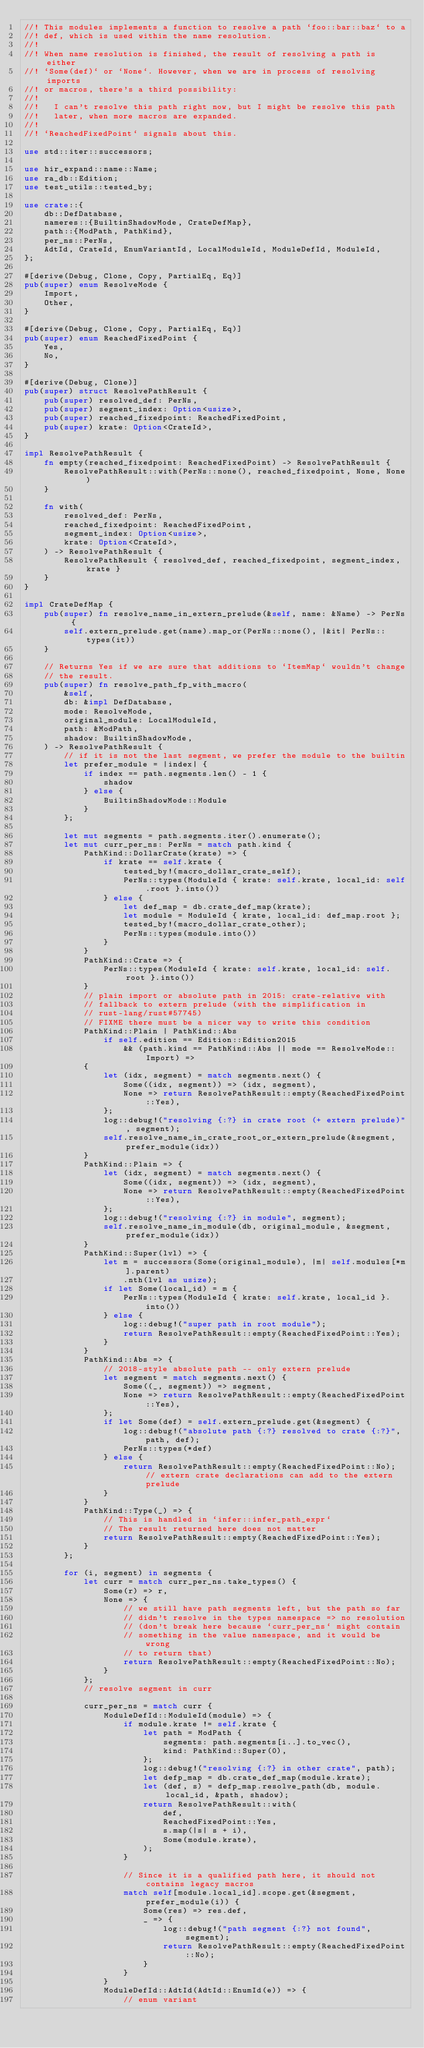Convert code to text. <code><loc_0><loc_0><loc_500><loc_500><_Rust_>//! This modules implements a function to resolve a path `foo::bar::baz` to a
//! def, which is used within the name resolution.
//!
//! When name resolution is finished, the result of resolving a path is either
//! `Some(def)` or `None`. However, when we are in process of resolving imports
//! or macros, there's a third possibility:
//!
//!   I can't resolve this path right now, but I might be resolve this path
//!   later, when more macros are expanded.
//!
//! `ReachedFixedPoint` signals about this.

use std::iter::successors;

use hir_expand::name::Name;
use ra_db::Edition;
use test_utils::tested_by;

use crate::{
    db::DefDatabase,
    nameres::{BuiltinShadowMode, CrateDefMap},
    path::{ModPath, PathKind},
    per_ns::PerNs,
    AdtId, CrateId, EnumVariantId, LocalModuleId, ModuleDefId, ModuleId,
};

#[derive(Debug, Clone, Copy, PartialEq, Eq)]
pub(super) enum ResolveMode {
    Import,
    Other,
}

#[derive(Debug, Clone, Copy, PartialEq, Eq)]
pub(super) enum ReachedFixedPoint {
    Yes,
    No,
}

#[derive(Debug, Clone)]
pub(super) struct ResolvePathResult {
    pub(super) resolved_def: PerNs,
    pub(super) segment_index: Option<usize>,
    pub(super) reached_fixedpoint: ReachedFixedPoint,
    pub(super) krate: Option<CrateId>,
}

impl ResolvePathResult {
    fn empty(reached_fixedpoint: ReachedFixedPoint) -> ResolvePathResult {
        ResolvePathResult::with(PerNs::none(), reached_fixedpoint, None, None)
    }

    fn with(
        resolved_def: PerNs,
        reached_fixedpoint: ReachedFixedPoint,
        segment_index: Option<usize>,
        krate: Option<CrateId>,
    ) -> ResolvePathResult {
        ResolvePathResult { resolved_def, reached_fixedpoint, segment_index, krate }
    }
}

impl CrateDefMap {
    pub(super) fn resolve_name_in_extern_prelude(&self, name: &Name) -> PerNs {
        self.extern_prelude.get(name).map_or(PerNs::none(), |&it| PerNs::types(it))
    }

    // Returns Yes if we are sure that additions to `ItemMap` wouldn't change
    // the result.
    pub(super) fn resolve_path_fp_with_macro(
        &self,
        db: &impl DefDatabase,
        mode: ResolveMode,
        original_module: LocalModuleId,
        path: &ModPath,
        shadow: BuiltinShadowMode,
    ) -> ResolvePathResult {
        // if it is not the last segment, we prefer the module to the builtin
        let prefer_module = |index| {
            if index == path.segments.len() - 1 {
                shadow
            } else {
                BuiltinShadowMode::Module
            }
        };

        let mut segments = path.segments.iter().enumerate();
        let mut curr_per_ns: PerNs = match path.kind {
            PathKind::DollarCrate(krate) => {
                if krate == self.krate {
                    tested_by!(macro_dollar_crate_self);
                    PerNs::types(ModuleId { krate: self.krate, local_id: self.root }.into())
                } else {
                    let def_map = db.crate_def_map(krate);
                    let module = ModuleId { krate, local_id: def_map.root };
                    tested_by!(macro_dollar_crate_other);
                    PerNs::types(module.into())
                }
            }
            PathKind::Crate => {
                PerNs::types(ModuleId { krate: self.krate, local_id: self.root }.into())
            }
            // plain import or absolute path in 2015: crate-relative with
            // fallback to extern prelude (with the simplification in
            // rust-lang/rust#57745)
            // FIXME there must be a nicer way to write this condition
            PathKind::Plain | PathKind::Abs
                if self.edition == Edition::Edition2015
                    && (path.kind == PathKind::Abs || mode == ResolveMode::Import) =>
            {
                let (idx, segment) = match segments.next() {
                    Some((idx, segment)) => (idx, segment),
                    None => return ResolvePathResult::empty(ReachedFixedPoint::Yes),
                };
                log::debug!("resolving {:?} in crate root (+ extern prelude)", segment);
                self.resolve_name_in_crate_root_or_extern_prelude(&segment, prefer_module(idx))
            }
            PathKind::Plain => {
                let (idx, segment) = match segments.next() {
                    Some((idx, segment)) => (idx, segment),
                    None => return ResolvePathResult::empty(ReachedFixedPoint::Yes),
                };
                log::debug!("resolving {:?} in module", segment);
                self.resolve_name_in_module(db, original_module, &segment, prefer_module(idx))
            }
            PathKind::Super(lvl) => {
                let m = successors(Some(original_module), |m| self.modules[*m].parent)
                    .nth(lvl as usize);
                if let Some(local_id) = m {
                    PerNs::types(ModuleId { krate: self.krate, local_id }.into())
                } else {
                    log::debug!("super path in root module");
                    return ResolvePathResult::empty(ReachedFixedPoint::Yes);
                }
            }
            PathKind::Abs => {
                // 2018-style absolute path -- only extern prelude
                let segment = match segments.next() {
                    Some((_, segment)) => segment,
                    None => return ResolvePathResult::empty(ReachedFixedPoint::Yes),
                };
                if let Some(def) = self.extern_prelude.get(&segment) {
                    log::debug!("absolute path {:?} resolved to crate {:?}", path, def);
                    PerNs::types(*def)
                } else {
                    return ResolvePathResult::empty(ReachedFixedPoint::No); // extern crate declarations can add to the extern prelude
                }
            }
            PathKind::Type(_) => {
                // This is handled in `infer::infer_path_expr`
                // The result returned here does not matter
                return ResolvePathResult::empty(ReachedFixedPoint::Yes);
            }
        };

        for (i, segment) in segments {
            let curr = match curr_per_ns.take_types() {
                Some(r) => r,
                None => {
                    // we still have path segments left, but the path so far
                    // didn't resolve in the types namespace => no resolution
                    // (don't break here because `curr_per_ns` might contain
                    // something in the value namespace, and it would be wrong
                    // to return that)
                    return ResolvePathResult::empty(ReachedFixedPoint::No);
                }
            };
            // resolve segment in curr

            curr_per_ns = match curr {
                ModuleDefId::ModuleId(module) => {
                    if module.krate != self.krate {
                        let path = ModPath {
                            segments: path.segments[i..].to_vec(),
                            kind: PathKind::Super(0),
                        };
                        log::debug!("resolving {:?} in other crate", path);
                        let defp_map = db.crate_def_map(module.krate);
                        let (def, s) = defp_map.resolve_path(db, module.local_id, &path, shadow);
                        return ResolvePathResult::with(
                            def,
                            ReachedFixedPoint::Yes,
                            s.map(|s| s + i),
                            Some(module.krate),
                        );
                    }

                    // Since it is a qualified path here, it should not contains legacy macros
                    match self[module.local_id].scope.get(&segment, prefer_module(i)) {
                        Some(res) => res.def,
                        _ => {
                            log::debug!("path segment {:?} not found", segment);
                            return ResolvePathResult::empty(ReachedFixedPoint::No);
                        }
                    }
                }
                ModuleDefId::AdtId(AdtId::EnumId(e)) => {
                    // enum variant</code> 